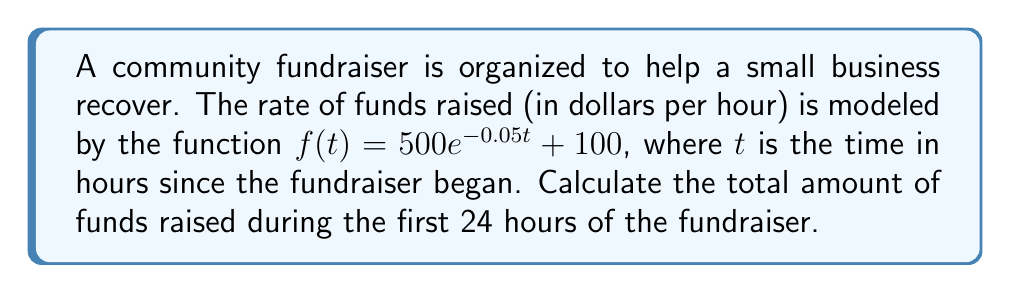Could you help me with this problem? To solve this problem, we need to use a definite integral to calculate the total funds raised over the 24-hour period. The steps are as follows:

1) The total funds raised is the area under the curve of the rate function $f(t)$ from $t=0$ to $t=24$.

2) We set up the definite integral:

   $$\int_0^{24} (500e^{-0.05t} + 100) dt$$

3) We can split this into two integrals:

   $$\int_0^{24} 500e^{-0.05t} dt + \int_0^{24} 100 dt$$

4) For the first integral, we use u-substitution:
   Let $u = -0.05t$, then $du = -0.05dt$ or $dt = -20du$
   When $t=0$, $u=0$; when $t=24$, $u=-1.2$

   $$-10000 \int_0^{-1.2} e^u du + 100t \Big|_0^{24}$$

5) Evaluate:

   $$-10000 [e^u]_0^{-1.2} + 100(24)$$
   
   $$-10000 (e^{-1.2} - e^0) + 2400$$
   
   $$-10000 (0.301194 - 1) + 2400$$
   
   $$6988.06 + 2400$$

6) The result is $9388.06 dollars.
Answer: $9388.06 